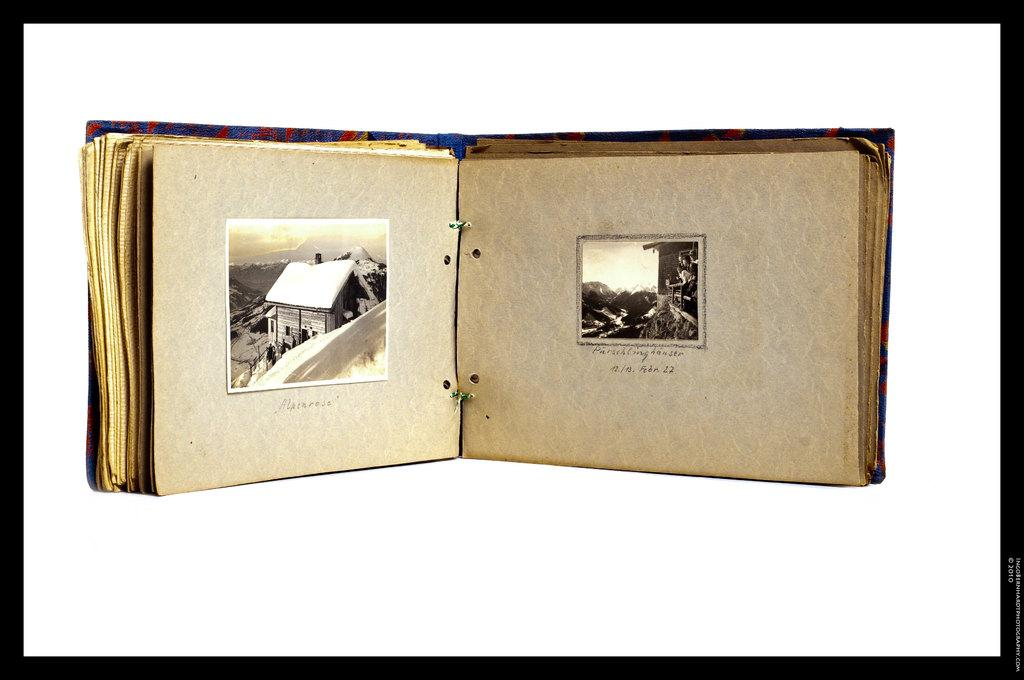What object can be seen in the image related to reading or learning? There is a book in the image. What type of structure is visible in the image? There is a house in the image. What part of the natural environment is visible in the image? The sky is visible in the image. What type of screw can be seen in the image? There is no screw present in the image. What type of business is being conducted in the image? The image does not depict any business activity. 